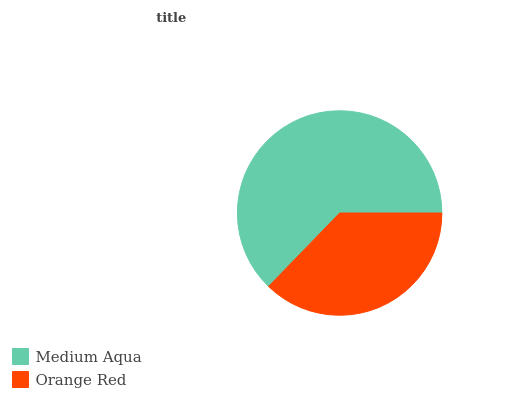Is Orange Red the minimum?
Answer yes or no. Yes. Is Medium Aqua the maximum?
Answer yes or no. Yes. Is Orange Red the maximum?
Answer yes or no. No. Is Medium Aqua greater than Orange Red?
Answer yes or no. Yes. Is Orange Red less than Medium Aqua?
Answer yes or no. Yes. Is Orange Red greater than Medium Aqua?
Answer yes or no. No. Is Medium Aqua less than Orange Red?
Answer yes or no. No. Is Medium Aqua the high median?
Answer yes or no. Yes. Is Orange Red the low median?
Answer yes or no. Yes. Is Orange Red the high median?
Answer yes or no. No. Is Medium Aqua the low median?
Answer yes or no. No. 